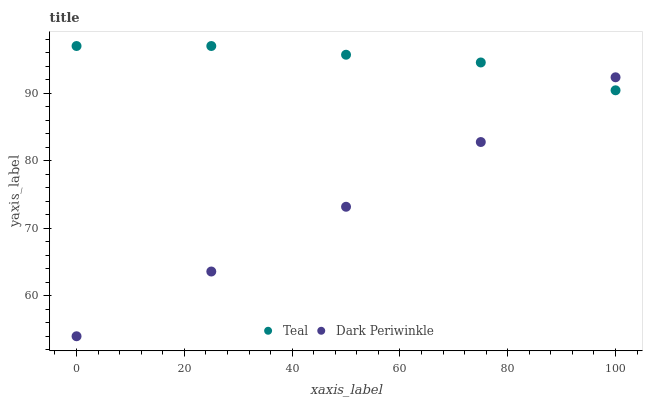Does Dark Periwinkle have the minimum area under the curve?
Answer yes or no. Yes. Does Teal have the maximum area under the curve?
Answer yes or no. Yes. Does Teal have the minimum area under the curve?
Answer yes or no. No. Is Dark Periwinkle the smoothest?
Answer yes or no. Yes. Is Teal the roughest?
Answer yes or no. Yes. Is Teal the smoothest?
Answer yes or no. No. Does Dark Periwinkle have the lowest value?
Answer yes or no. Yes. Does Teal have the lowest value?
Answer yes or no. No. Does Teal have the highest value?
Answer yes or no. Yes. Does Teal intersect Dark Periwinkle?
Answer yes or no. Yes. Is Teal less than Dark Periwinkle?
Answer yes or no. No. Is Teal greater than Dark Periwinkle?
Answer yes or no. No. 